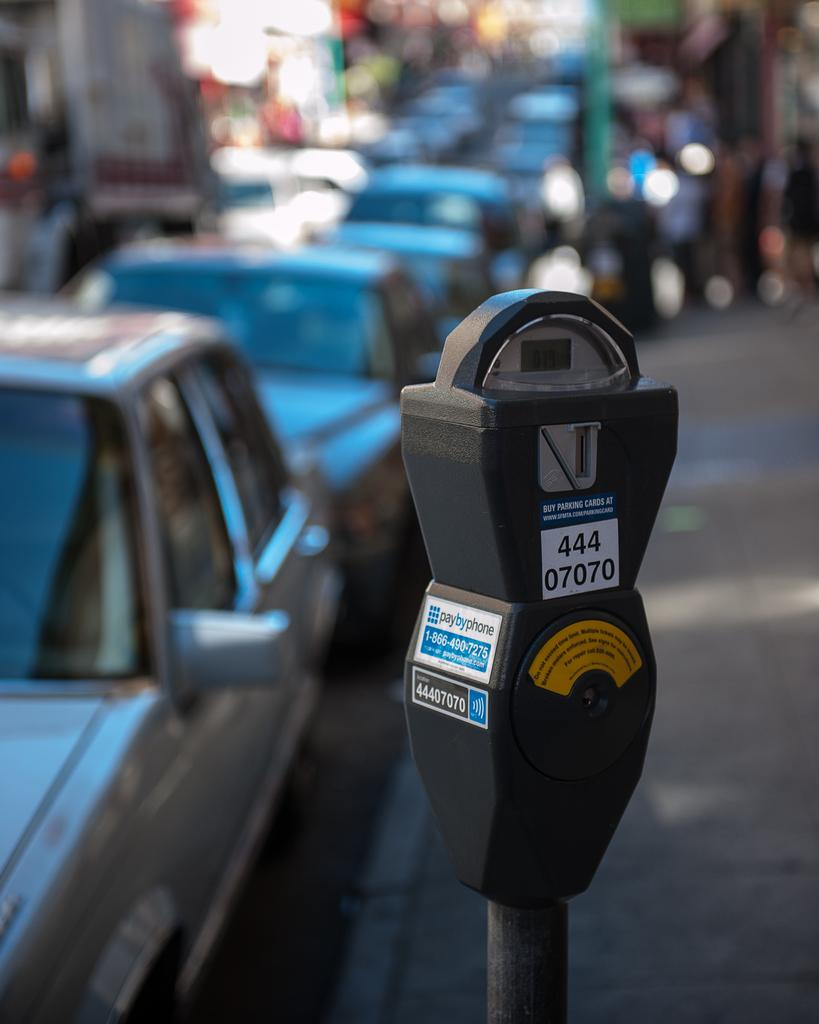<image>
Provide a brief description of the given image. The parking meter has the number 44407070 on it. 